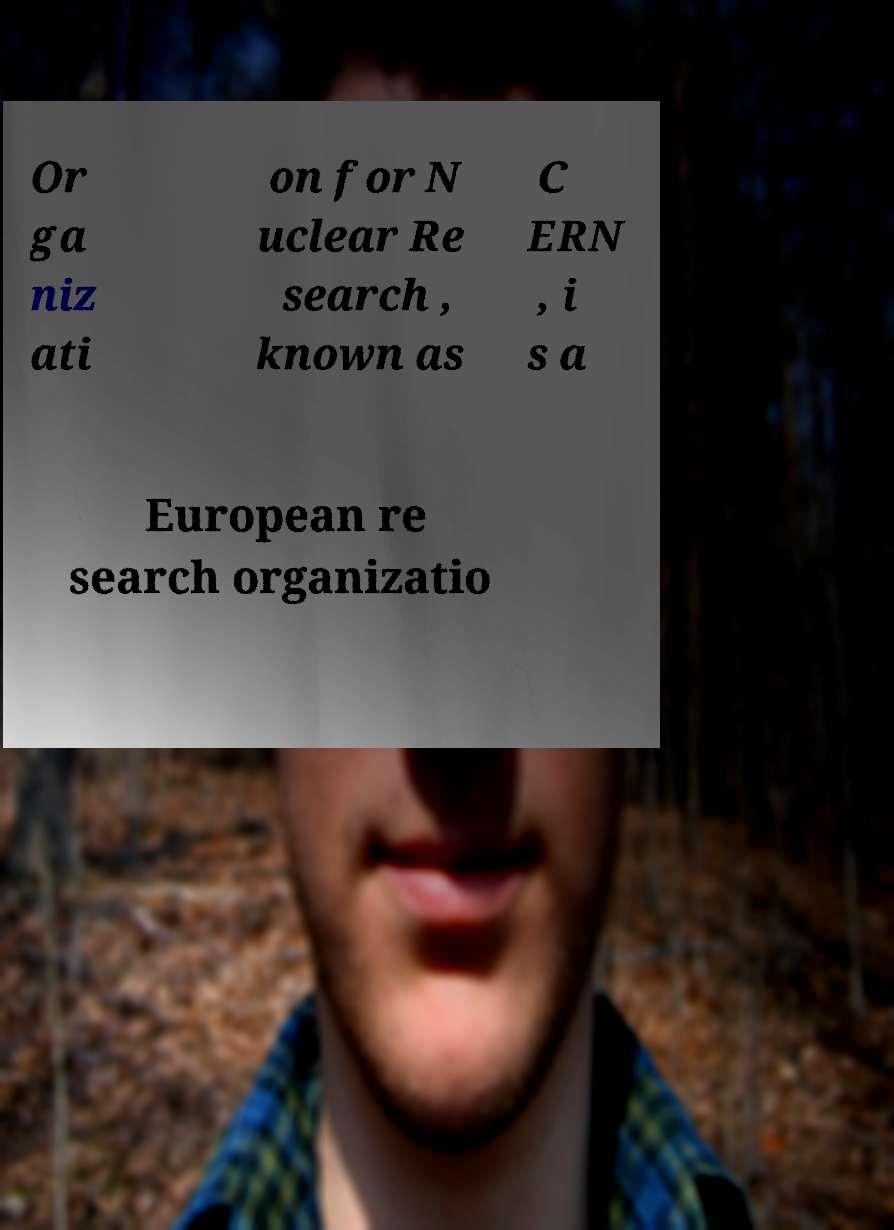Please read and relay the text visible in this image. What does it say? Or ga niz ati on for N uclear Re search , known as C ERN , i s a European re search organizatio 